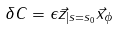Convert formula to latex. <formula><loc_0><loc_0><loc_500><loc_500>\delta C = \epsilon \vec { z } _ { | s = s _ { 0 } } \vec { x } _ { \phi }</formula> 